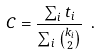Convert formula to latex. <formula><loc_0><loc_0><loc_500><loc_500>C = \frac { \sum _ { i } t _ { i } } { \sum _ { i } \binom { k _ { i } } { 2 } } \ .</formula> 